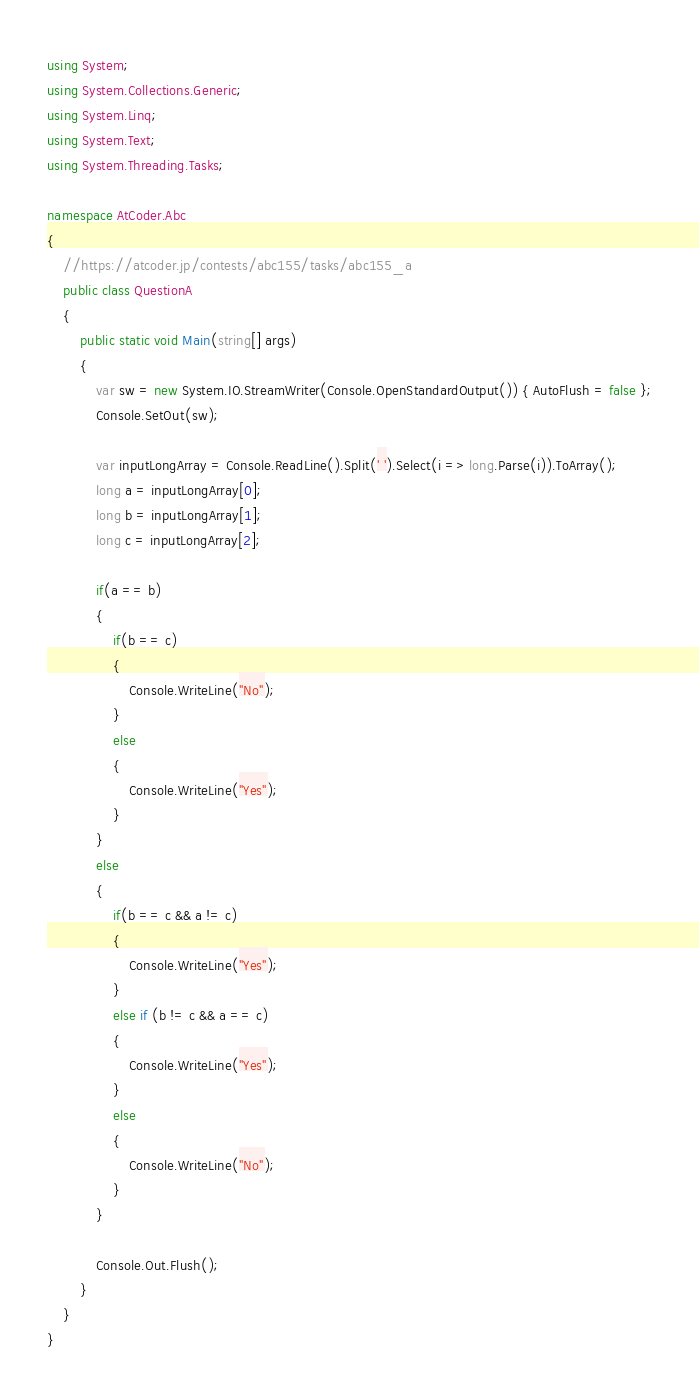<code> <loc_0><loc_0><loc_500><loc_500><_C#_>using System;
using System.Collections.Generic;
using System.Linq;
using System.Text;
using System.Threading.Tasks;

namespace AtCoder.Abc
{
    //https://atcoder.jp/contests/abc155/tasks/abc155_a
    public class QuestionA
    {
        public static void Main(string[] args)
        {
            var sw = new System.IO.StreamWriter(Console.OpenStandardOutput()) { AutoFlush = false };
            Console.SetOut(sw);

            var inputLongArray = Console.ReadLine().Split(' ').Select(i => long.Parse(i)).ToArray();
            long a = inputLongArray[0];
            long b = inputLongArray[1];
            long c = inputLongArray[2];

            if(a == b)
            {
                if(b == c)
                {
                    Console.WriteLine("No");
                }
                else
                {
                    Console.WriteLine("Yes");
                }
            }
            else
            {
                if(b == c && a != c)
                {
                    Console.WriteLine("Yes");
                }
                else if (b != c && a == c)
                {
                    Console.WriteLine("Yes");
                }
                else
                {
                    Console.WriteLine("No");
                }
            }

            Console.Out.Flush();
        }
    }
}
</code> 